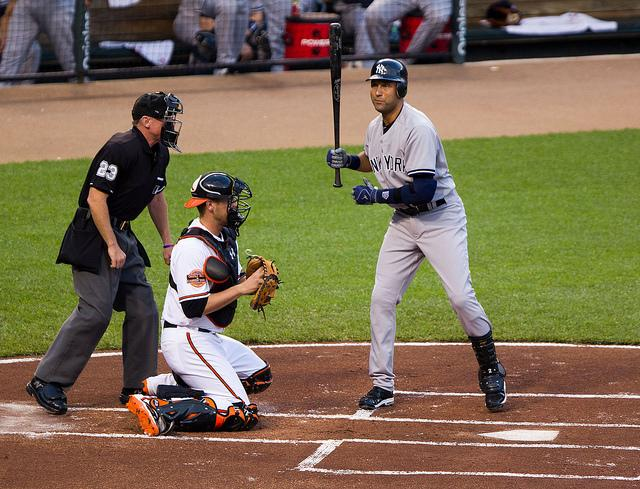Who is the man up to bat? derek jeter 